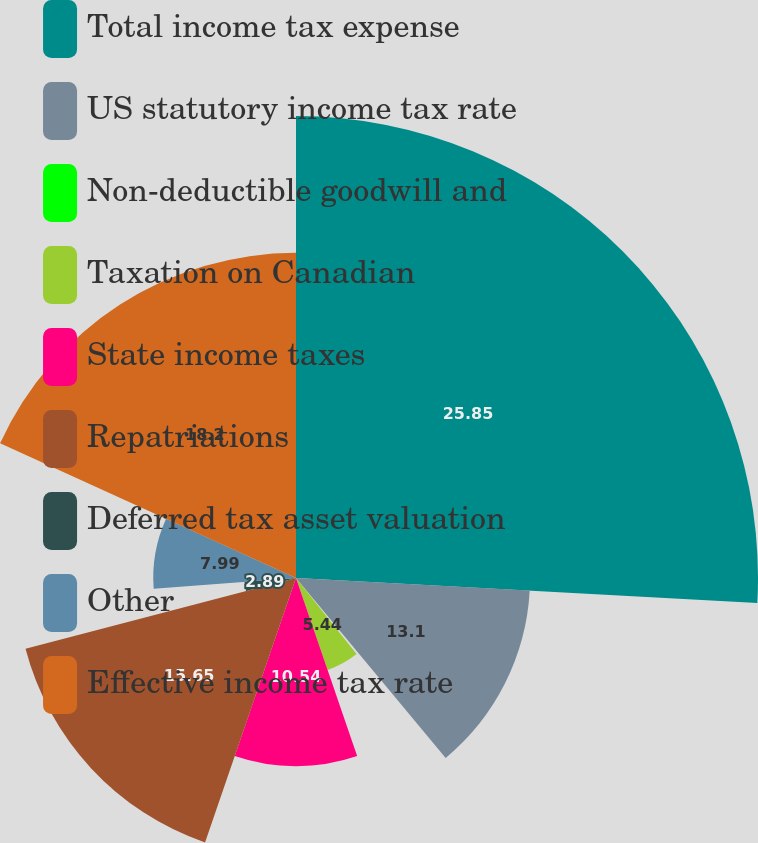Convert chart. <chart><loc_0><loc_0><loc_500><loc_500><pie_chart><fcel>Total income tax expense<fcel>US statutory income tax rate<fcel>Non-deductible goodwill and<fcel>Taxation on Canadian<fcel>State income taxes<fcel>Repatriations<fcel>Deferred tax asset valuation<fcel>Other<fcel>Effective income tax rate<nl><fcel>25.86%<fcel>13.1%<fcel>0.34%<fcel>5.44%<fcel>10.54%<fcel>15.65%<fcel>2.89%<fcel>7.99%<fcel>18.2%<nl></chart> 